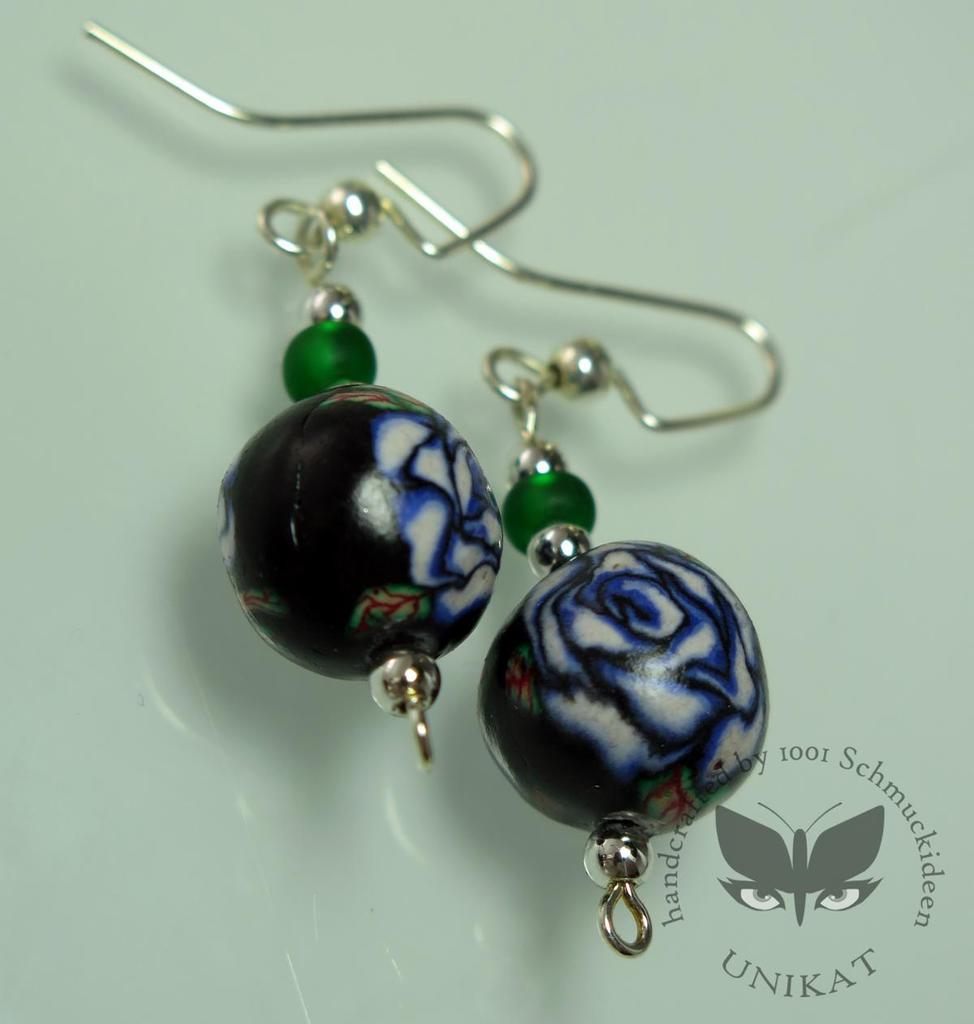What type of accessory is featured in the image? There is a pair of earrings in the image. What else can be seen on the bottom right side of the image? There is text and an image on the bottom right side of the image. What is visible in the background of the image? There is a wall in the background of the image. Can you describe the sail on the tramp in the image? There is no sail or tramp present in the image; it features a pair of earrings, text, an image, and a wall in the background. 